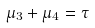Convert formula to latex. <formula><loc_0><loc_0><loc_500><loc_500>\mu _ { 3 } + \mu _ { 4 } = \tau</formula> 